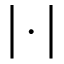<formula> <loc_0><loc_0><loc_500><loc_500>\left | \cdot \right |</formula> 